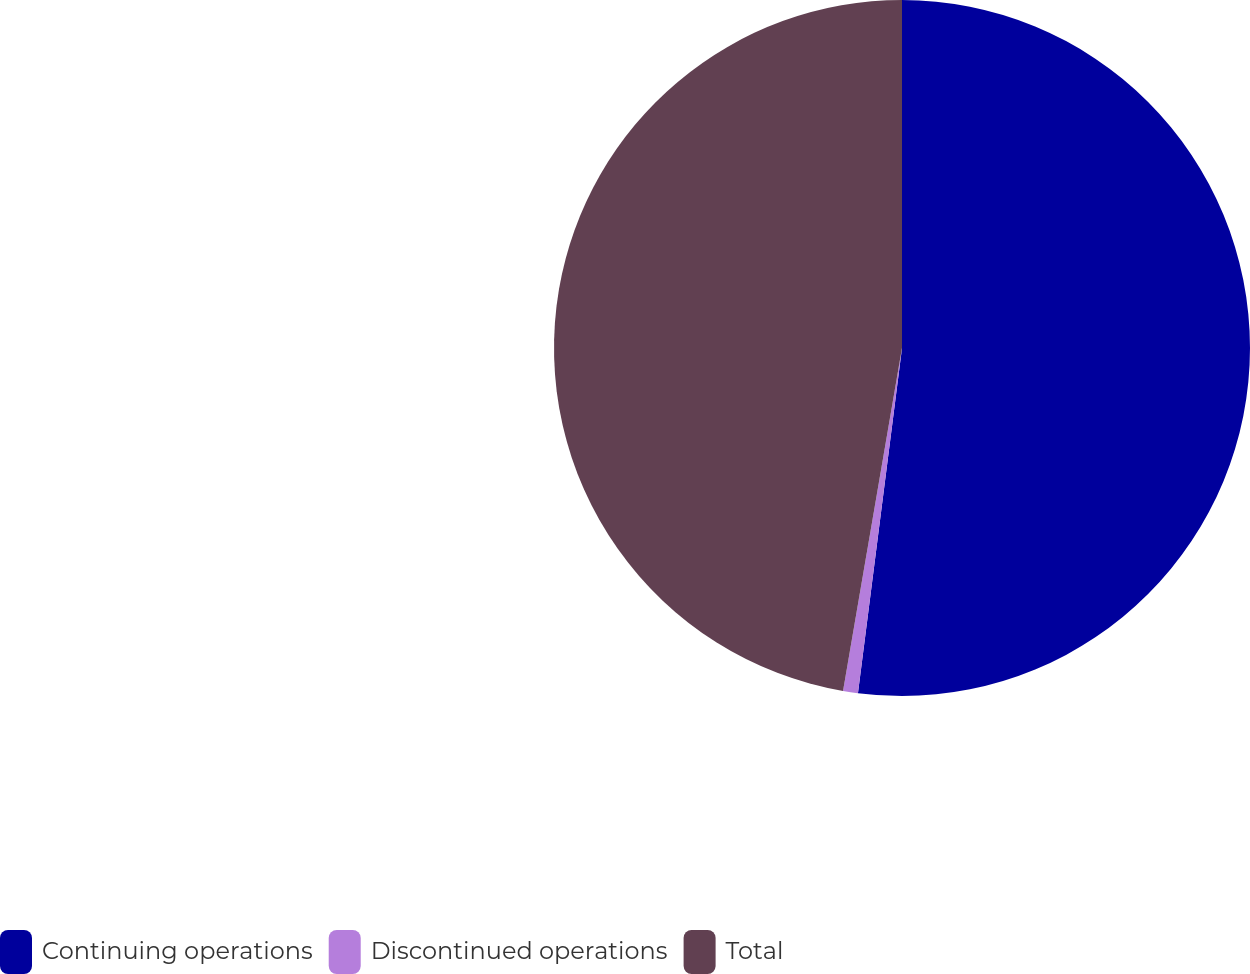Convert chart to OTSL. <chart><loc_0><loc_0><loc_500><loc_500><pie_chart><fcel>Continuing operations<fcel>Discontinued operations<fcel>Total<nl><fcel>52.02%<fcel>0.69%<fcel>47.29%<nl></chart> 